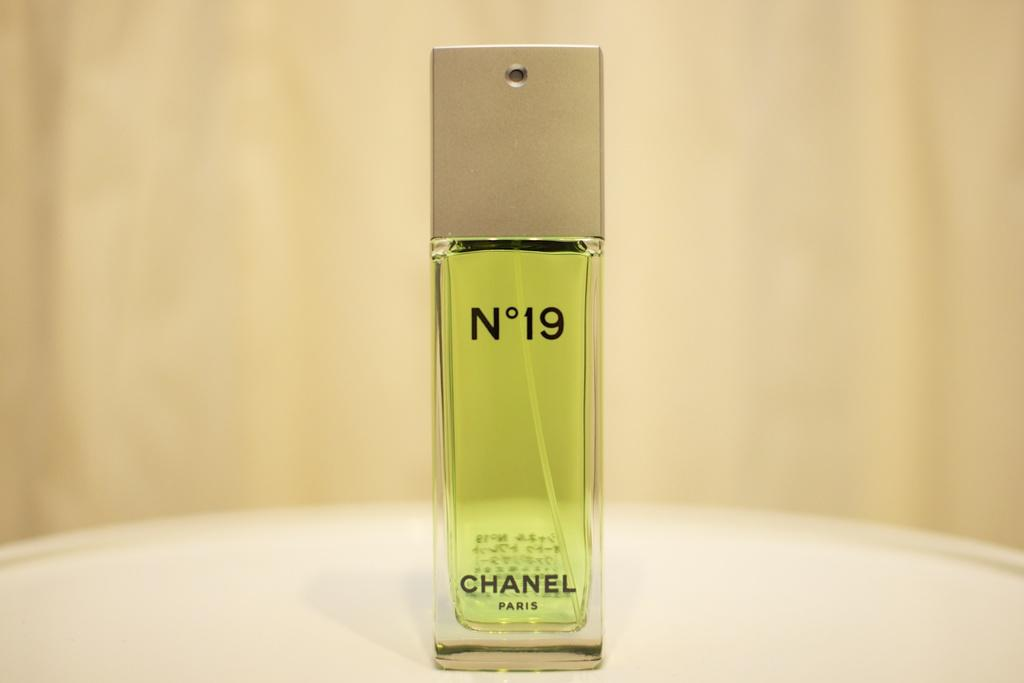<image>
Give a short and clear explanation of the subsequent image. A rectangular spray bottle of Chanel No 119. 